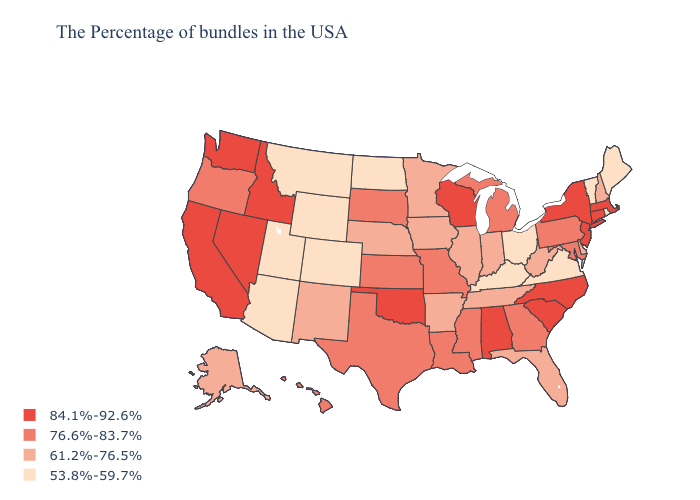Among the states that border Utah , does Nevada have the highest value?
Concise answer only. Yes. Does the map have missing data?
Quick response, please. No. Does Maine have the lowest value in the Northeast?
Answer briefly. Yes. What is the value of Maine?
Concise answer only. 53.8%-59.7%. What is the highest value in the USA?
Write a very short answer. 84.1%-92.6%. Which states have the highest value in the USA?
Concise answer only. Massachusetts, Connecticut, New York, New Jersey, North Carolina, South Carolina, Alabama, Wisconsin, Oklahoma, Idaho, Nevada, California, Washington. Which states have the lowest value in the USA?
Short answer required. Maine, Rhode Island, Vermont, Virginia, Ohio, Kentucky, North Dakota, Wyoming, Colorado, Utah, Montana, Arizona. Does Wyoming have the lowest value in the USA?
Quick response, please. Yes. Does South Carolina have the highest value in the South?
Keep it brief. Yes. Which states have the lowest value in the West?
Answer briefly. Wyoming, Colorado, Utah, Montana, Arizona. Which states hav the highest value in the West?
Concise answer only. Idaho, Nevada, California, Washington. Among the states that border South Carolina , which have the highest value?
Be succinct. North Carolina. How many symbols are there in the legend?
Keep it brief. 4. Name the states that have a value in the range 61.2%-76.5%?
Write a very short answer. New Hampshire, Delaware, West Virginia, Florida, Indiana, Tennessee, Illinois, Arkansas, Minnesota, Iowa, Nebraska, New Mexico, Alaska. Name the states that have a value in the range 76.6%-83.7%?
Answer briefly. Maryland, Pennsylvania, Georgia, Michigan, Mississippi, Louisiana, Missouri, Kansas, Texas, South Dakota, Oregon, Hawaii. 